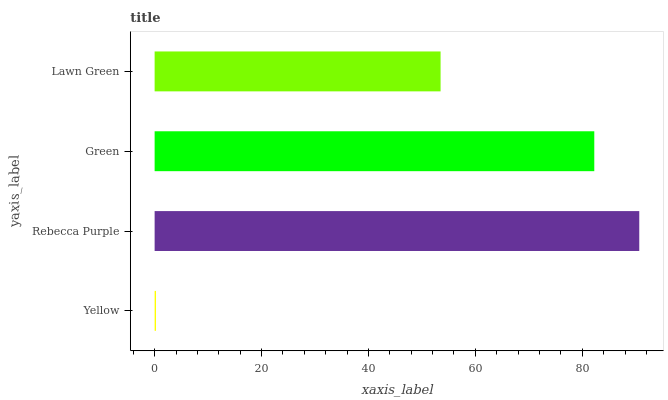Is Yellow the minimum?
Answer yes or no. Yes. Is Rebecca Purple the maximum?
Answer yes or no. Yes. Is Green the minimum?
Answer yes or no. No. Is Green the maximum?
Answer yes or no. No. Is Rebecca Purple greater than Green?
Answer yes or no. Yes. Is Green less than Rebecca Purple?
Answer yes or no. Yes. Is Green greater than Rebecca Purple?
Answer yes or no. No. Is Rebecca Purple less than Green?
Answer yes or no. No. Is Green the high median?
Answer yes or no. Yes. Is Lawn Green the low median?
Answer yes or no. Yes. Is Yellow the high median?
Answer yes or no. No. Is Green the low median?
Answer yes or no. No. 